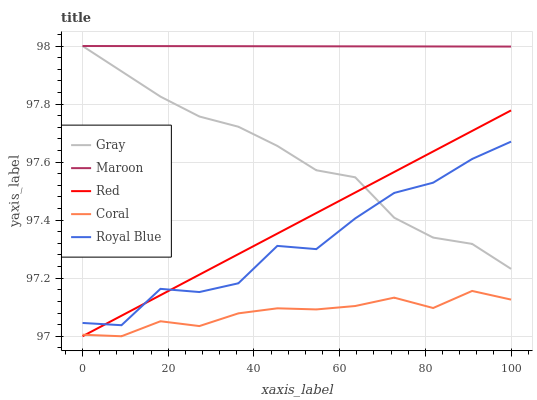Does Coral have the minimum area under the curve?
Answer yes or no. Yes. Does Maroon have the maximum area under the curve?
Answer yes or no. Yes. Does Red have the minimum area under the curve?
Answer yes or no. No. Does Red have the maximum area under the curve?
Answer yes or no. No. Is Maroon the smoothest?
Answer yes or no. Yes. Is Royal Blue the roughest?
Answer yes or no. Yes. Is Coral the smoothest?
Answer yes or no. No. Is Coral the roughest?
Answer yes or no. No. Does Maroon have the lowest value?
Answer yes or no. No. Does Red have the highest value?
Answer yes or no. No. Is Coral less than Maroon?
Answer yes or no. Yes. Is Maroon greater than Red?
Answer yes or no. Yes. Does Coral intersect Maroon?
Answer yes or no. No. 